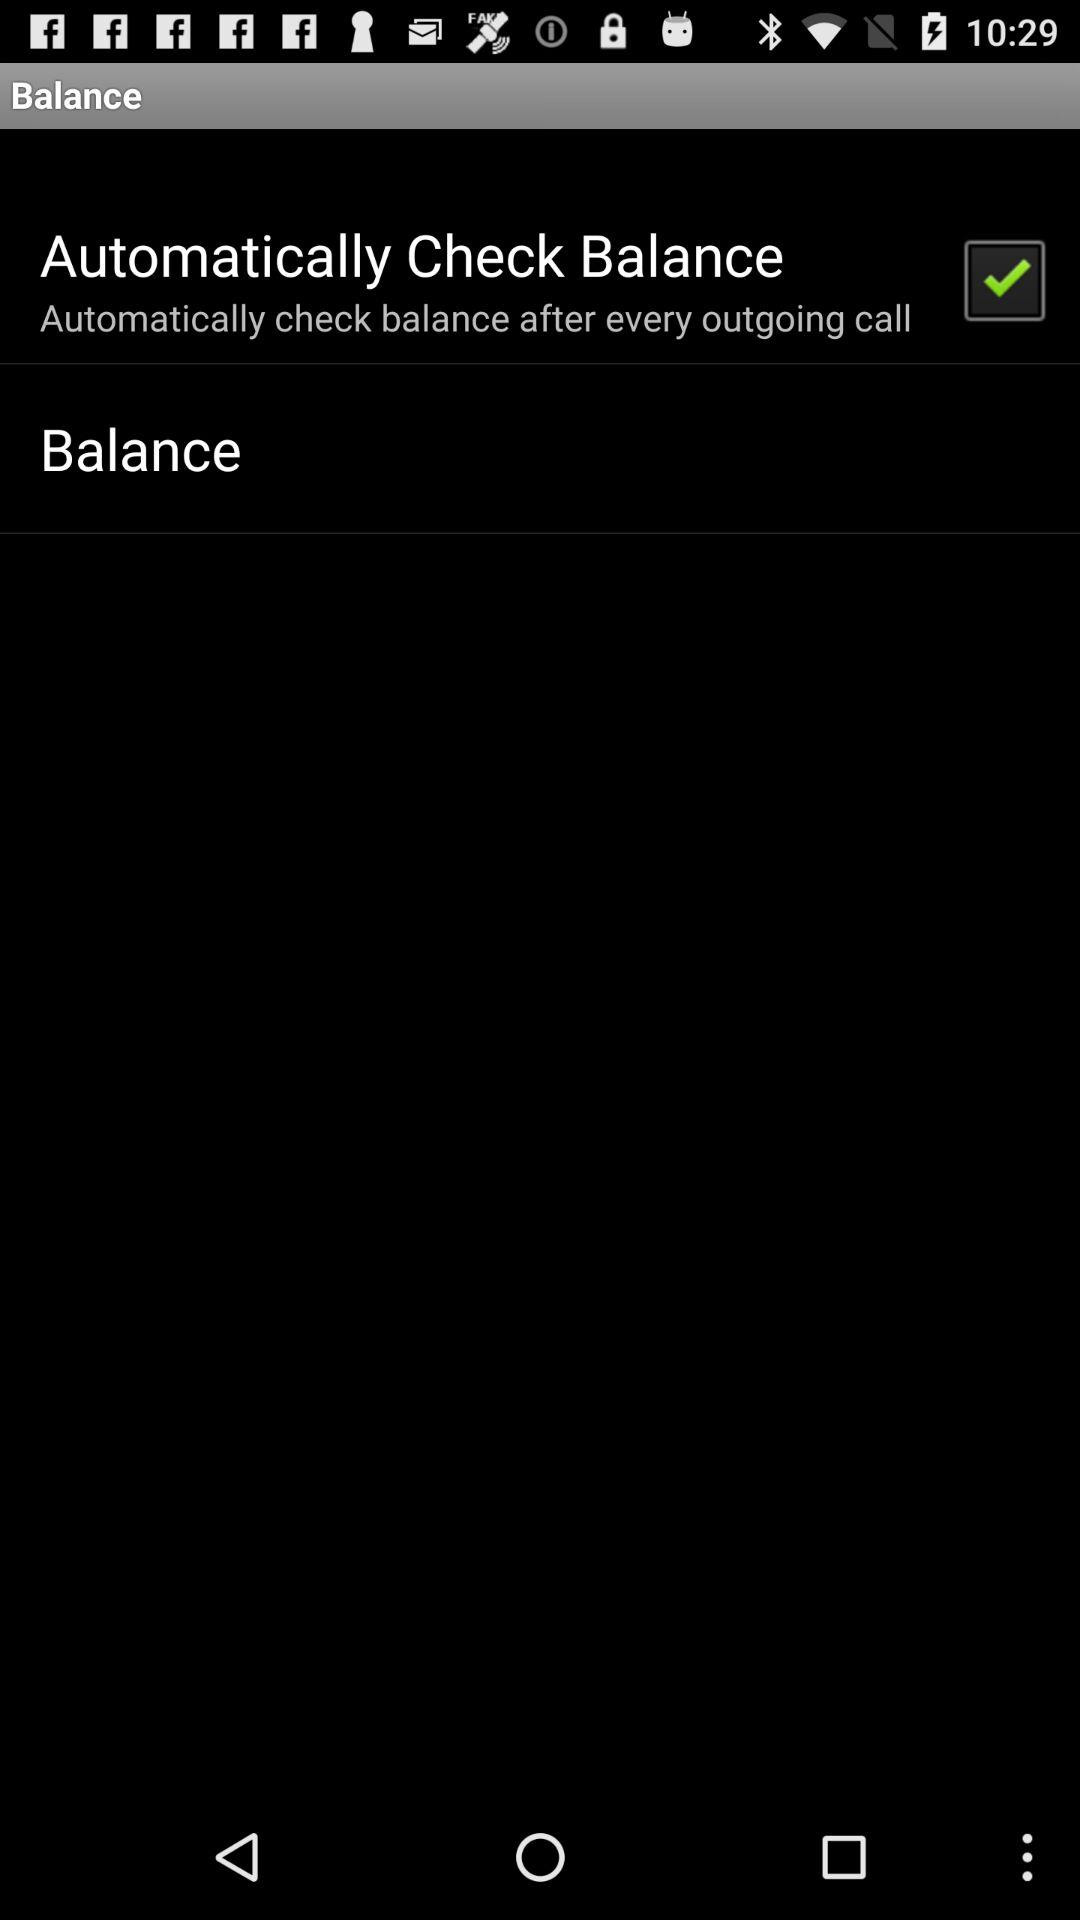Which option is marked as checked? The option is "Automatically Check Balance". 